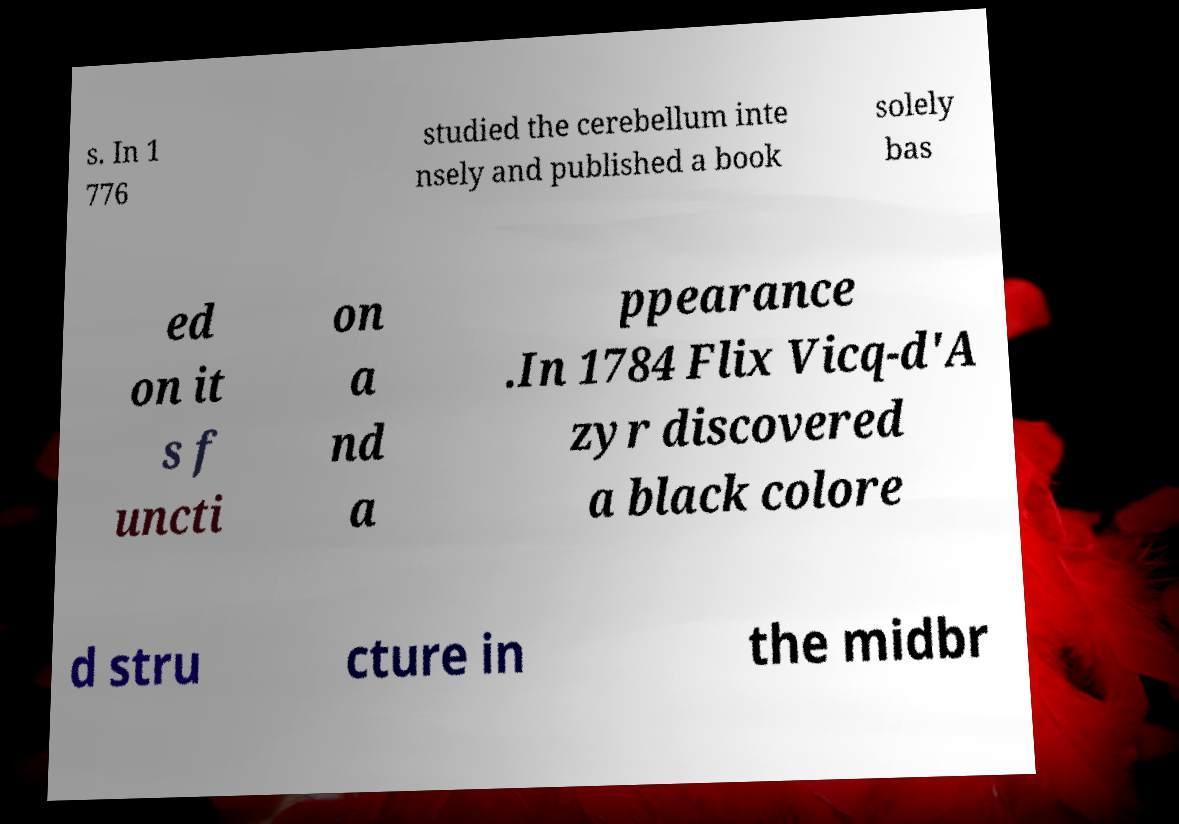Could you extract and type out the text from this image? s. In 1 776 studied the cerebellum inte nsely and published a book solely bas ed on it s f uncti on a nd a ppearance .In 1784 Flix Vicq-d'A zyr discovered a black colore d stru cture in the midbr 